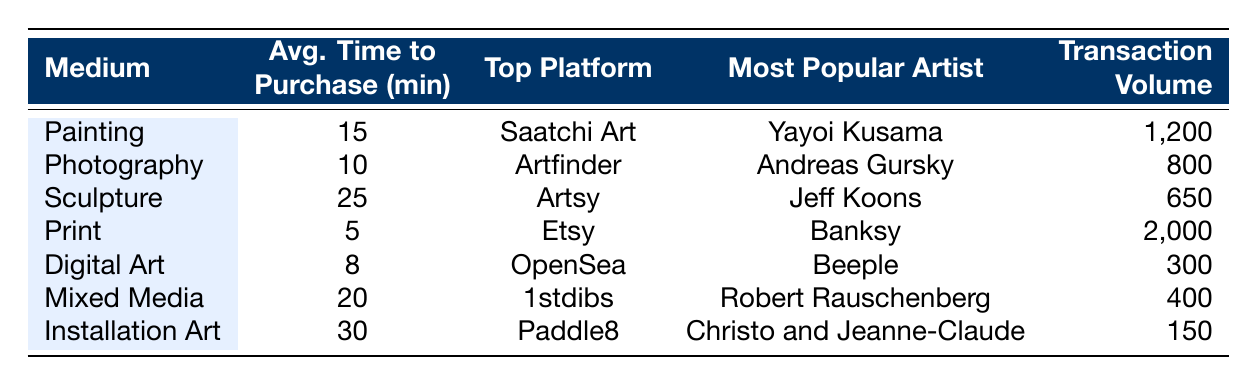What is the average time to purchase for Print? The table shows that the average time to purchase for Print is listed as 5 minutes.
Answer: 5 minutes Which medium has the highest transaction volume? By comparing the transaction volumes in the table, Print has the highest volume at 2,000.
Answer: Print Is the most popular artist in Sculpture Jeff Koons? Yes, according to the table, Jeff Koons is indeed listed as the most popular artist for Sculpture.
Answer: Yes What is the difference in average time to purchase between Installation Art and Photography? The average time to purchase for Installation Art is 30 minutes and for Photography is 10 minutes. The difference is 30 - 10 = 20 minutes.
Answer: 20 minutes Which platform is the top platform for Digital Art? The table indicates that the top platform for Digital Art is OpenSea.
Answer: OpenSea How many more transactions does Print have than Digital Art? The transaction volume for Print is 2,000 while for Digital Art, it is 300. The difference is 2,000 - 300 = 1,700 transactions.
Answer: 1,700 transactions What is the average time to purchase for all mediums combined? To find the average, we add the average times (15 + 10 + 25 + 5 + 8 + 20 + 30 = 113) and divide by the number of mediums (7). Thus, the average time is 113 / 7 ≈ 16.14 minutes.
Answer: Approximately 16.14 minutes Which medium takes the longest to purchase, and how long does it take? Installation Art takes the longest time to purchase at 30 minutes, as indicated in the table.
Answer: Installation Art, 30 minutes Is there any medium where the average time to purchase is less than 10 minutes? Yes, according to the table, Print (5 minutes) and Digital Art (8 minutes) both have average times under 10 minutes.
Answer: Yes What percentage of the total transaction volume is accounted for by Sculpture? The total transaction volume is 2,000 + 800 + 650 + 2000 + 300 + 400 + 150 = 4,500. Sculpture has a volume of 650, so the percentage is (650 / 4,500) * 100 ≈ 14.44%.
Answer: Approximately 14.44% 